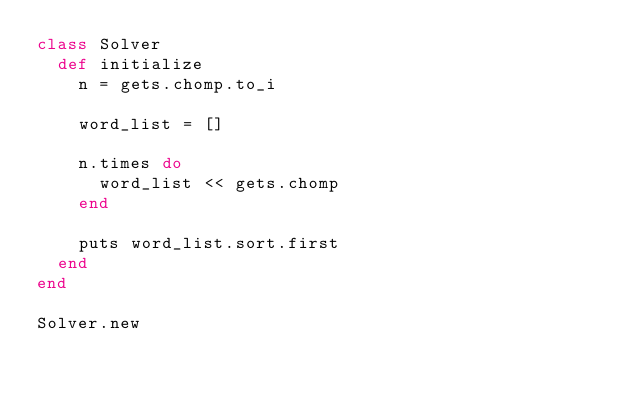Convert code to text. <code><loc_0><loc_0><loc_500><loc_500><_Ruby_>class Solver
  def initialize
    n = gets.chomp.to_i

    word_list = []

    n.times do
      word_list << gets.chomp
    end

    puts word_list.sort.first
  end
end

Solver.new</code> 